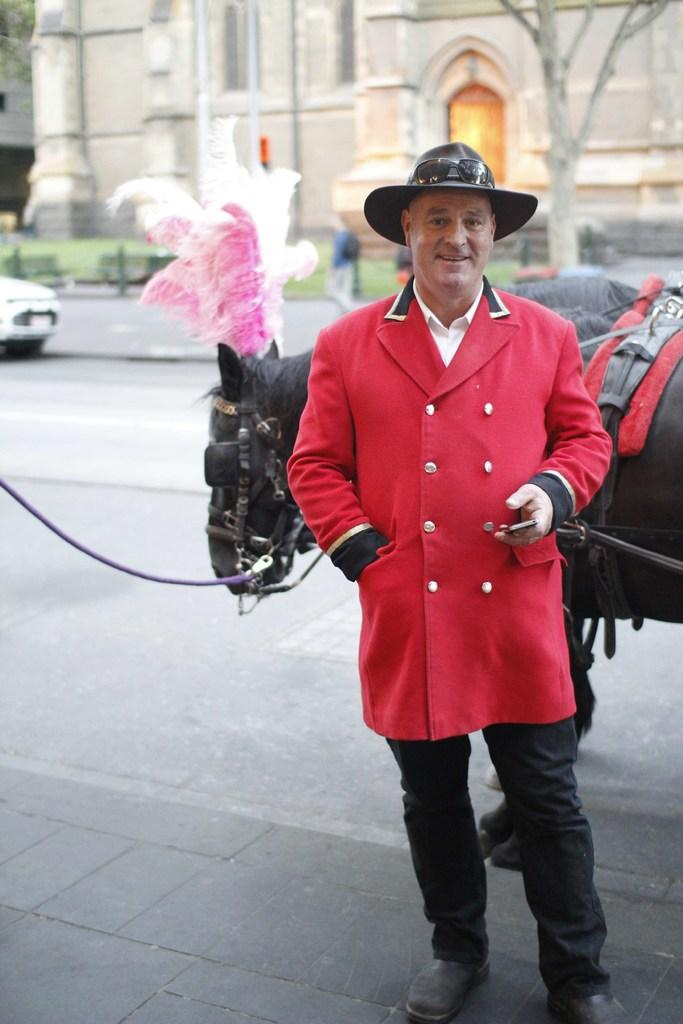What is the main subject in the image? There is a person standing in the image. What is the horse in the image decorated with? The horse is decorated with feathers in the image. What can be seen on the road in the image? There is a vehicle on the road in the image. What type of structures are present in the image? There are buildings in the image. What type of vegetation is present in the image? There is grass and plants in the image. What type of seating is available in the image? There are benches in the image. What type of natural elements are present in the image? There are trees in the image. What month is depicted in the image? There is no indication of a specific month in the image. What type of box is used to store the plants in the image? There is no box present in the image; the plants are not stored in a box. 